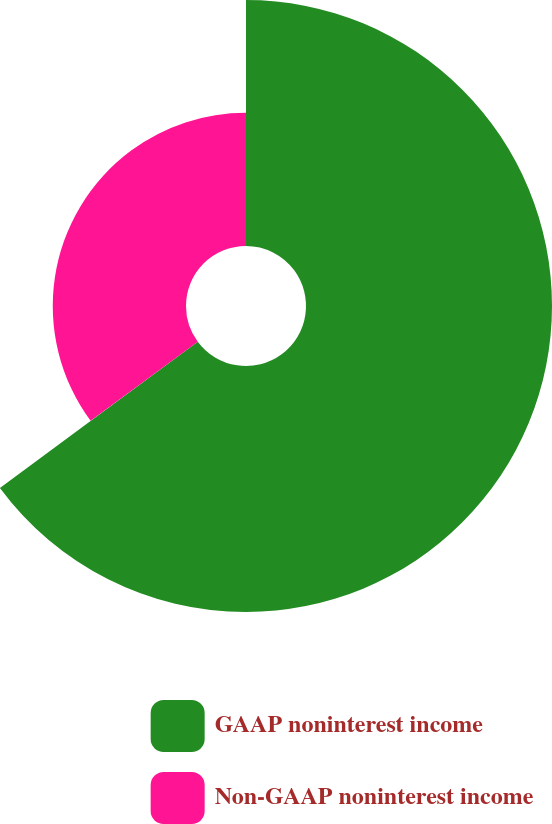Convert chart. <chart><loc_0><loc_0><loc_500><loc_500><pie_chart><fcel>GAAP noninterest income<fcel>Non-GAAP noninterest income<nl><fcel>64.87%<fcel>35.13%<nl></chart> 